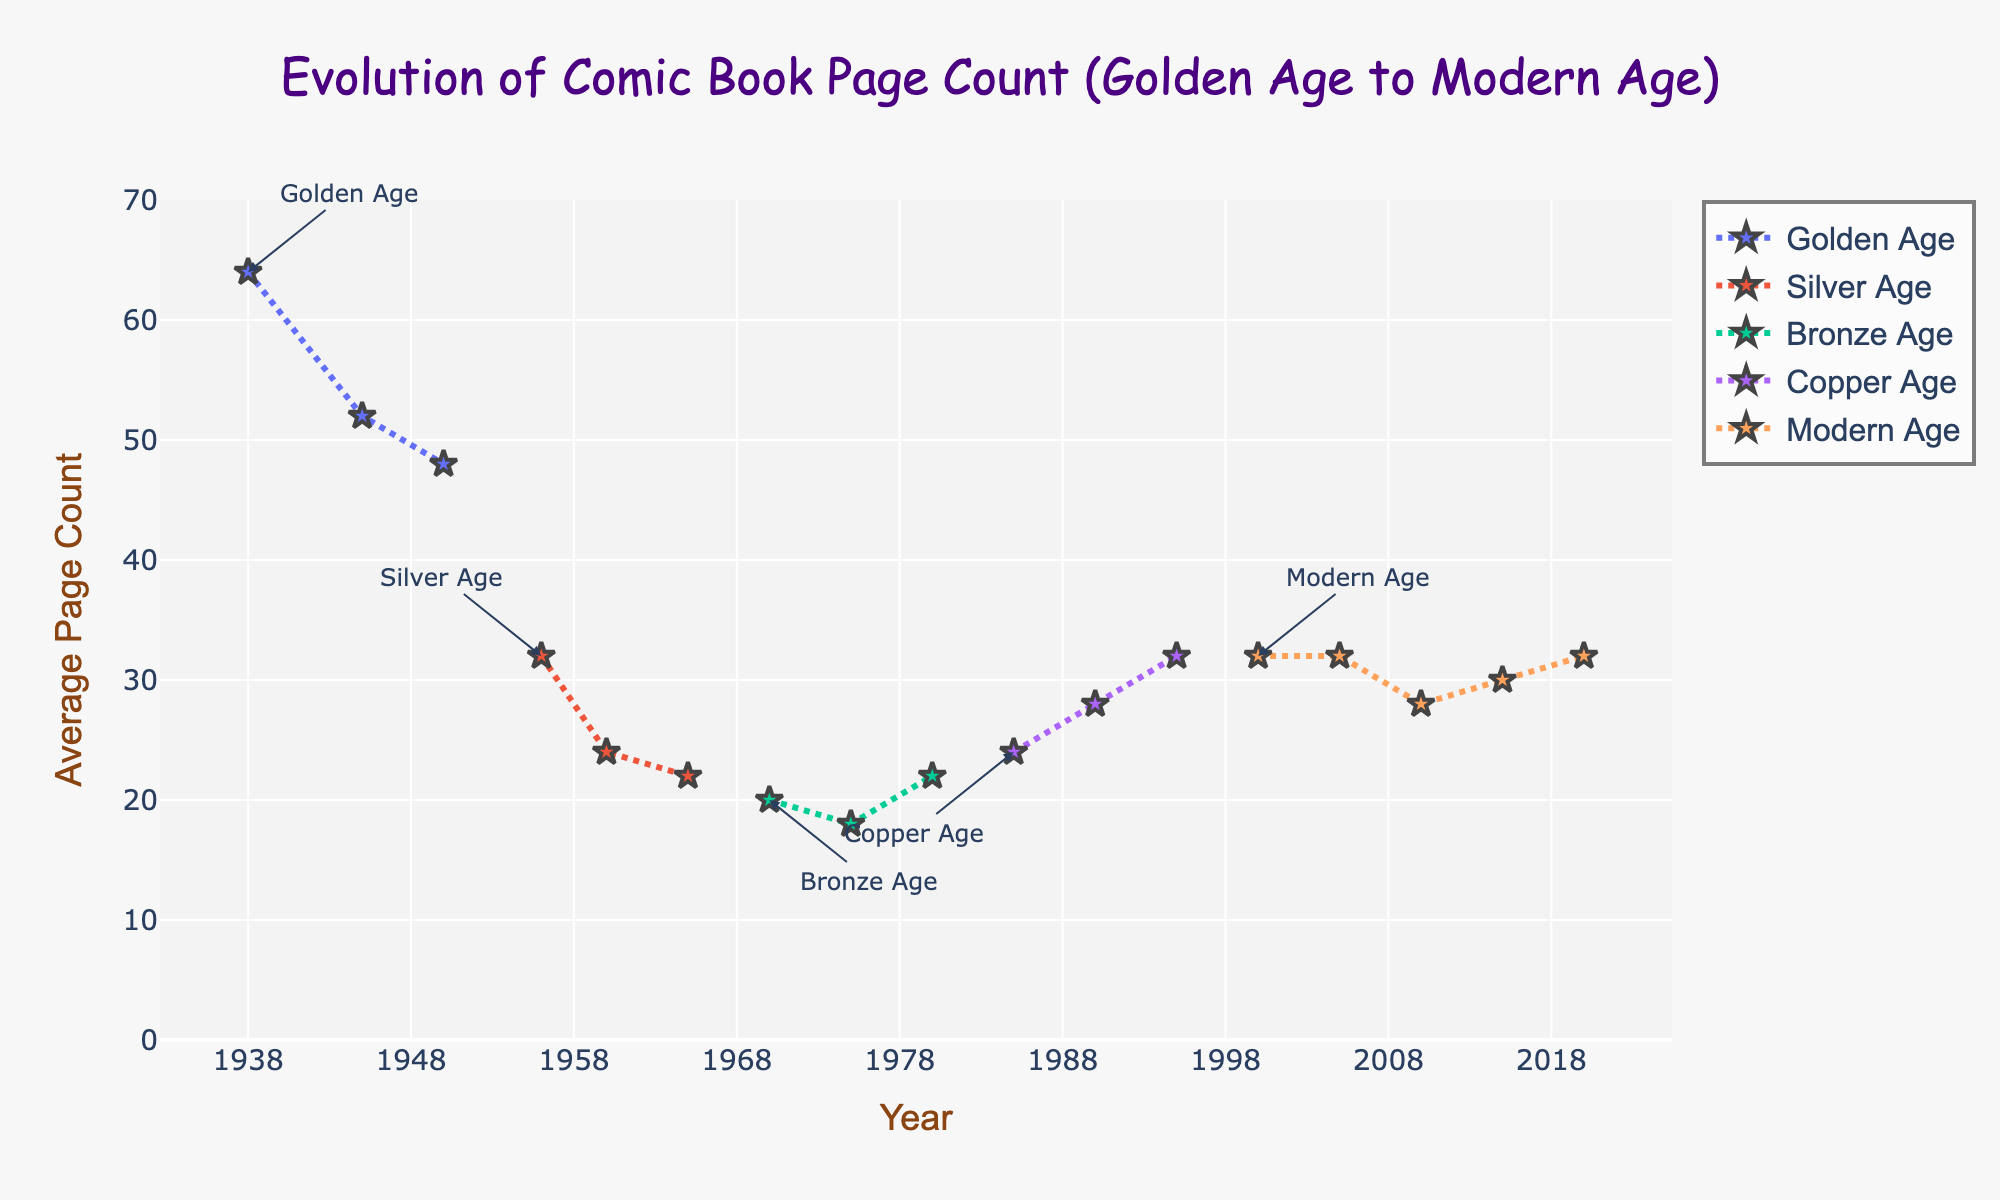What's the overall trend in the average page count of comic books from the Golden Age to the Modern Age? From the chart, we can observe a gradual decrease in the average page count from the Golden Age to the Silver Age, followed by slight fluctuations in the Bronze and Copper Ages, and relatively stability with minor variations in the Modern Age. This indicates the average page count has decreased overall with some fluctuations throughout the years.
Answer: Decreasing with fluctuations Compare the average page count between the start of the Golden Age (1938) and the end of the Golden Age (1950). How did it change? The average page count at the start of the Golden Age (1938) is 64, while at the end of the Golden Age (1950) it is 48. To find the change, subtract the 1950 value from the 1938 value: 64 - 48 = 16. This shows a decrease of 16 pages.
Answer: Decreased by 16 pages During which Age do we observe the lowest average page count, and what is the value? By examining the plotted lines, the Silver Age has the lowest point on the y-axis for average page count. This minimum value is 22 pages in 1965.
Answer: Silver Age, 22 pages Identify the Age and the year with the highest average page count. The highest average page count is seen at the start of the Golden Age in 1938, where the value is 64 pages.
Answer: Golden Age, 1938 How does the average page count in the year 2000 (Modern Age) compare to that in 1995 (end of Copper Age)? The average page count in the year 2000 is 32, while in 1995 it is also 32. Therefore, there is no change, and the values are equal.
Answer: Equal, 32 pages Calculate the average page count over the entire Silver Age (1956-1965). The average page counts for the years 1956, 1960, and 1965 are 32, 24, and 22 respectively. To find the overall average, sum these values: 32 + 24 + 22 = 78, and then divide by the number of data points: 78 / 3 = 26.
Answer: 26 pages Compare the initial average page count of the Bronze Age (1970) with the final average page count of the Modern Age (2020). In 1970 (Bronze Age), the average page count is 20. In 2020 (Modern Age), the average page count is 32. To compare, we consider the difference: 32 - 20 = 12. The average page count increased by 12 pages.
Answer: Increased by 12 pages 